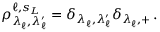Convert formula to latex. <formula><loc_0><loc_0><loc_500><loc_500>\rho _ { \lambda _ { \ell } ^ { \, } , \lambda _ { \ell } ^ { \prime } } ^ { \ell , s _ { L } } = \delta _ { \lambda _ { \ell } ^ { \, } , \lambda _ { \ell } ^ { \prime } } \delta _ { \lambda _ { \ell } ^ { \, } , + } \, .</formula> 